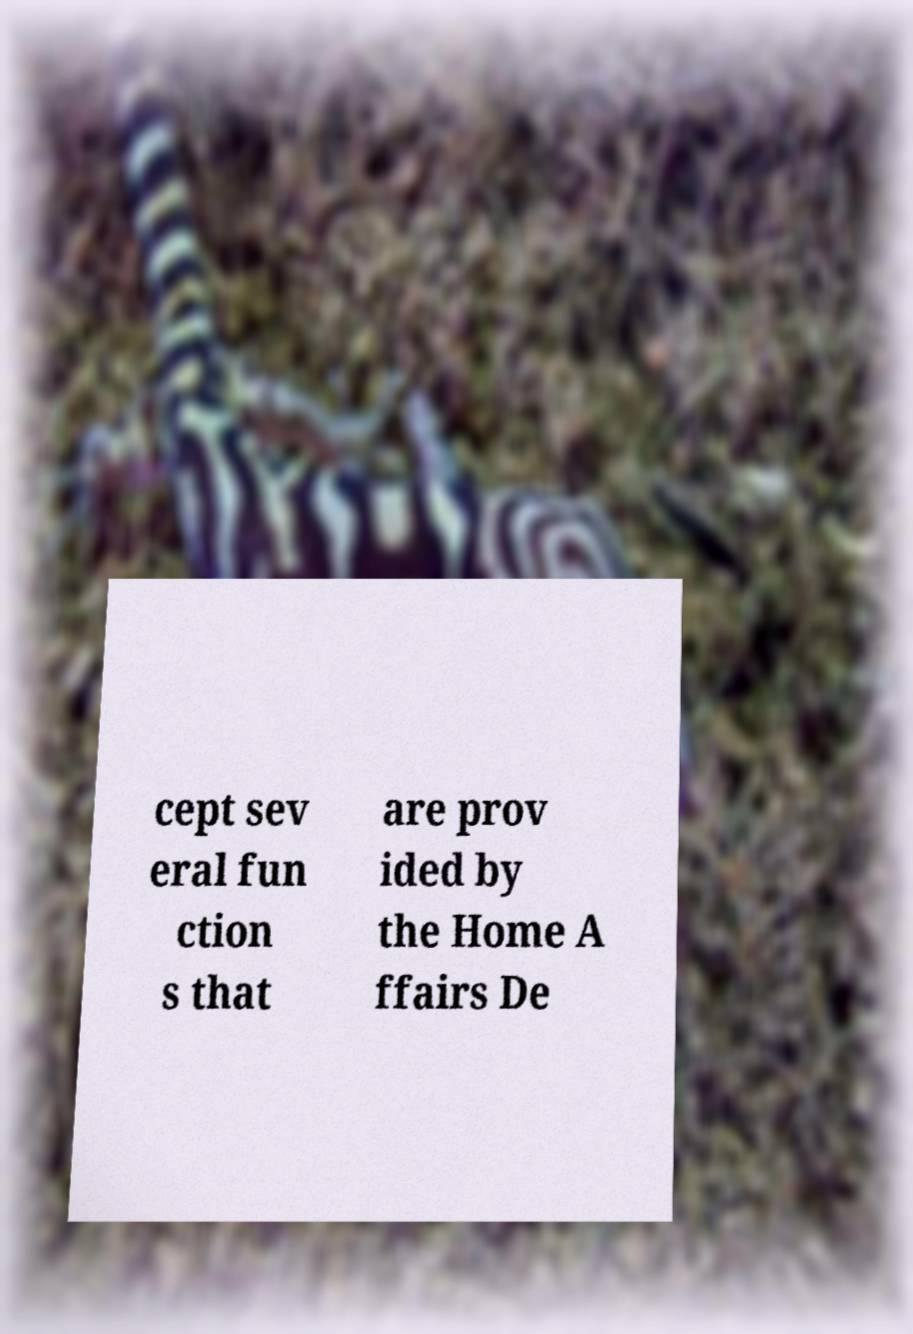Can you read and provide the text displayed in the image?This photo seems to have some interesting text. Can you extract and type it out for me? cept sev eral fun ction s that are prov ided by the Home A ffairs De 